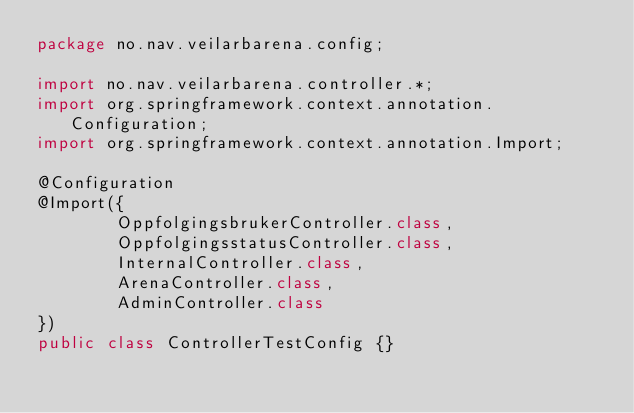Convert code to text. <code><loc_0><loc_0><loc_500><loc_500><_Java_>package no.nav.veilarbarena.config;

import no.nav.veilarbarena.controller.*;
import org.springframework.context.annotation.Configuration;
import org.springframework.context.annotation.Import;

@Configuration
@Import({
        OppfolgingsbrukerController.class,
        OppfolgingsstatusController.class,
        InternalController.class,
        ArenaController.class,
        AdminController.class
})
public class ControllerTestConfig {}
</code> 